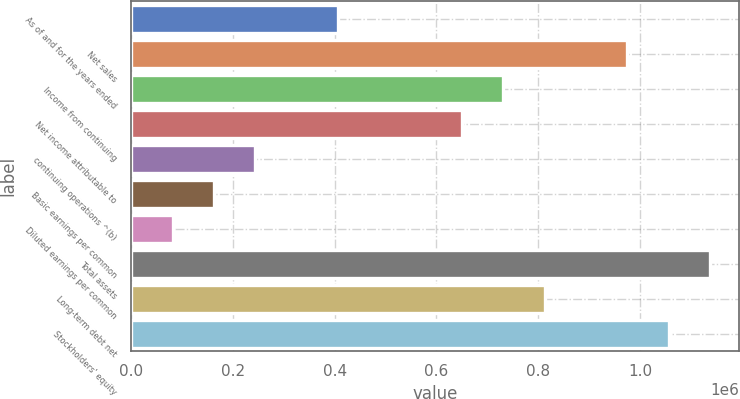<chart> <loc_0><loc_0><loc_500><loc_500><bar_chart><fcel>As of and for the years ended<fcel>Net sales<fcel>Income from continuing<fcel>Net income attributable to<fcel>continuing operations ^(b)<fcel>Basic earnings per common<fcel>Diluted earnings per common<fcel>Total assets<fcel>Long-term debt net<fcel>Stockholders' equity<nl><fcel>406237<fcel>974966<fcel>731225<fcel>649978<fcel>243743<fcel>162496<fcel>81248.5<fcel>1.13746e+06<fcel>812472<fcel>1.05621e+06<nl></chart> 